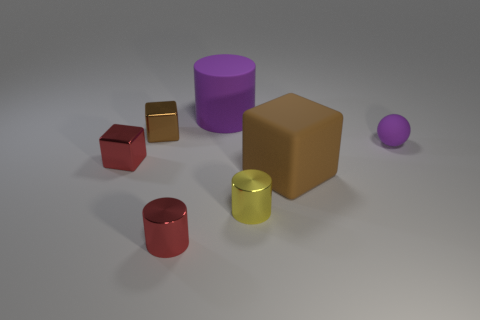Subtract all small yellow cylinders. How many cylinders are left? 2 Subtract all gray balls. How many brown blocks are left? 2 Subtract 2 cylinders. How many cylinders are left? 1 Add 1 purple objects. How many objects exist? 8 Subtract all red cylinders. How many cylinders are left? 2 Add 7 rubber balls. How many rubber balls are left? 8 Add 3 big matte cubes. How many big matte cubes exist? 4 Subtract 0 blue blocks. How many objects are left? 7 Subtract all cylinders. How many objects are left? 4 Subtract all red spheres. Subtract all yellow cylinders. How many spheres are left? 1 